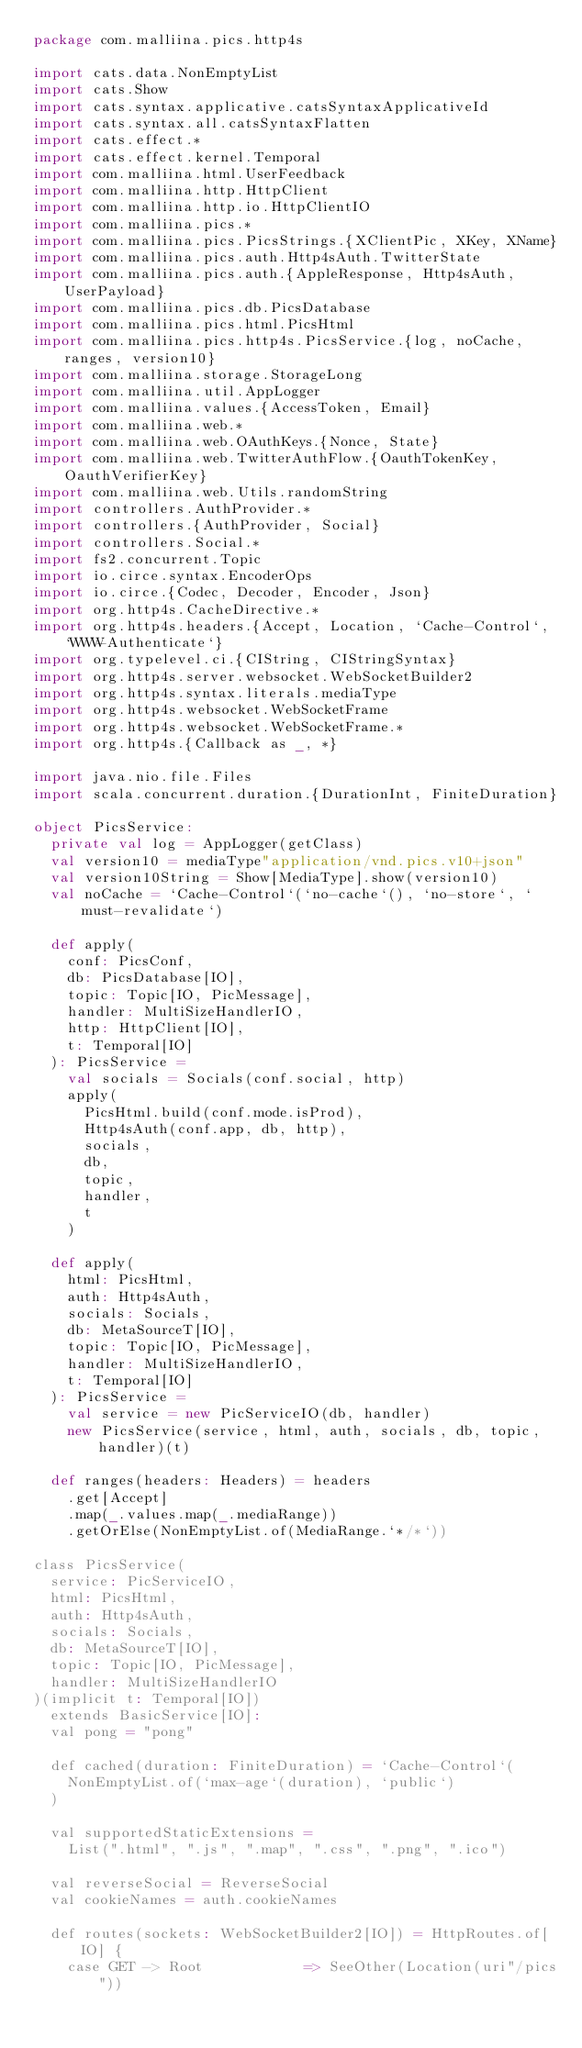<code> <loc_0><loc_0><loc_500><loc_500><_Scala_>package com.malliina.pics.http4s

import cats.data.NonEmptyList
import cats.Show
import cats.syntax.applicative.catsSyntaxApplicativeId
import cats.syntax.all.catsSyntaxFlatten
import cats.effect.*
import cats.effect.kernel.Temporal
import com.malliina.html.UserFeedback
import com.malliina.http.HttpClient
import com.malliina.http.io.HttpClientIO
import com.malliina.pics.*
import com.malliina.pics.PicsStrings.{XClientPic, XKey, XName}
import com.malliina.pics.auth.Http4sAuth.TwitterState
import com.malliina.pics.auth.{AppleResponse, Http4sAuth, UserPayload}
import com.malliina.pics.db.PicsDatabase
import com.malliina.pics.html.PicsHtml
import com.malliina.pics.http4s.PicsService.{log, noCache, ranges, version10}
import com.malliina.storage.StorageLong
import com.malliina.util.AppLogger
import com.malliina.values.{AccessToken, Email}
import com.malliina.web.*
import com.malliina.web.OAuthKeys.{Nonce, State}
import com.malliina.web.TwitterAuthFlow.{OauthTokenKey, OauthVerifierKey}
import com.malliina.web.Utils.randomString
import controllers.AuthProvider.*
import controllers.{AuthProvider, Social}
import controllers.Social.*
import fs2.concurrent.Topic
import io.circe.syntax.EncoderOps
import io.circe.{Codec, Decoder, Encoder, Json}
import org.http4s.CacheDirective.*
import org.http4s.headers.{Accept, Location, `Cache-Control`, `WWW-Authenticate`}
import org.typelevel.ci.{CIString, CIStringSyntax}
import org.http4s.server.websocket.WebSocketBuilder2
import org.http4s.syntax.literals.mediaType
import org.http4s.websocket.WebSocketFrame
import org.http4s.websocket.WebSocketFrame.*
import org.http4s.{Callback as _, *}

import java.nio.file.Files
import scala.concurrent.duration.{DurationInt, FiniteDuration}

object PicsService:
  private val log = AppLogger(getClass)
  val version10 = mediaType"application/vnd.pics.v10+json"
  val version10String = Show[MediaType].show(version10)
  val noCache = `Cache-Control`(`no-cache`(), `no-store`, `must-revalidate`)

  def apply(
    conf: PicsConf,
    db: PicsDatabase[IO],
    topic: Topic[IO, PicMessage],
    handler: MultiSizeHandlerIO,
    http: HttpClient[IO],
    t: Temporal[IO]
  ): PicsService =
    val socials = Socials(conf.social, http)
    apply(
      PicsHtml.build(conf.mode.isProd),
      Http4sAuth(conf.app, db, http),
      socials,
      db,
      topic,
      handler,
      t
    )

  def apply(
    html: PicsHtml,
    auth: Http4sAuth,
    socials: Socials,
    db: MetaSourceT[IO],
    topic: Topic[IO, PicMessage],
    handler: MultiSizeHandlerIO,
    t: Temporal[IO]
  ): PicsService =
    val service = new PicServiceIO(db, handler)
    new PicsService(service, html, auth, socials, db, topic, handler)(t)

  def ranges(headers: Headers) = headers
    .get[Accept]
    .map(_.values.map(_.mediaRange))
    .getOrElse(NonEmptyList.of(MediaRange.`*/*`))

class PicsService(
  service: PicServiceIO,
  html: PicsHtml,
  auth: Http4sAuth,
  socials: Socials,
  db: MetaSourceT[IO],
  topic: Topic[IO, PicMessage],
  handler: MultiSizeHandlerIO
)(implicit t: Temporal[IO])
  extends BasicService[IO]:
  val pong = "pong"

  def cached(duration: FiniteDuration) = `Cache-Control`(
    NonEmptyList.of(`max-age`(duration), `public`)
  )

  val supportedStaticExtensions =
    List(".html", ".js", ".map", ".css", ".png", ".ico")

  val reverseSocial = ReverseSocial
  val cookieNames = auth.cookieNames

  def routes(sockets: WebSocketBuilder2[IO]) = HttpRoutes.of[IO] {
    case GET -> Root            => SeeOther(Location(uri"/pics"))</code> 